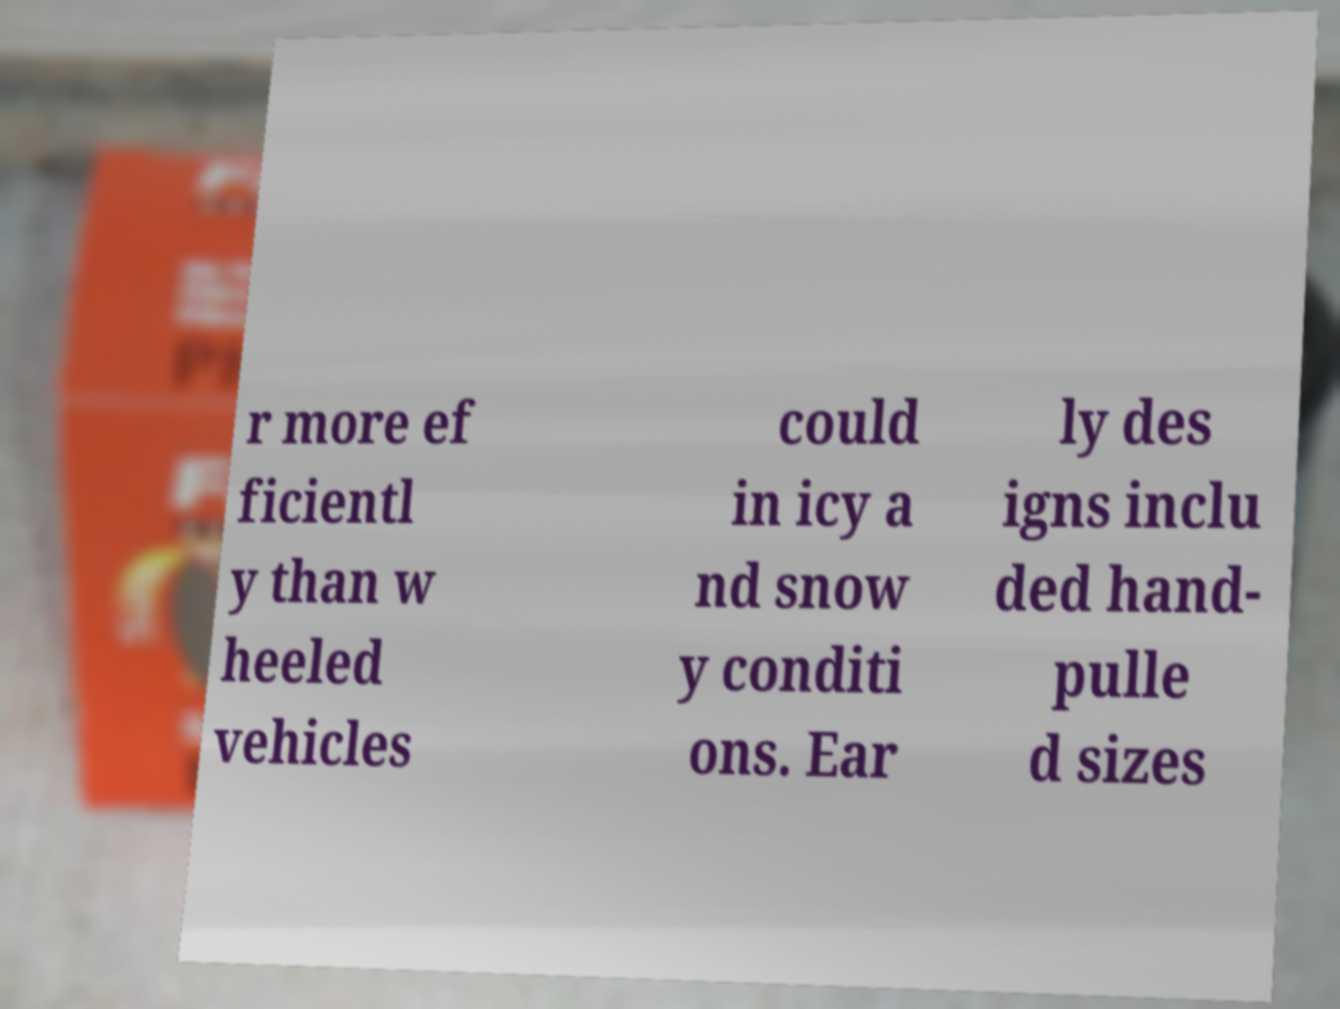What messages or text are displayed in this image? I need them in a readable, typed format. r more ef ficientl y than w heeled vehicles could in icy a nd snow y conditi ons. Ear ly des igns inclu ded hand- pulle d sizes 